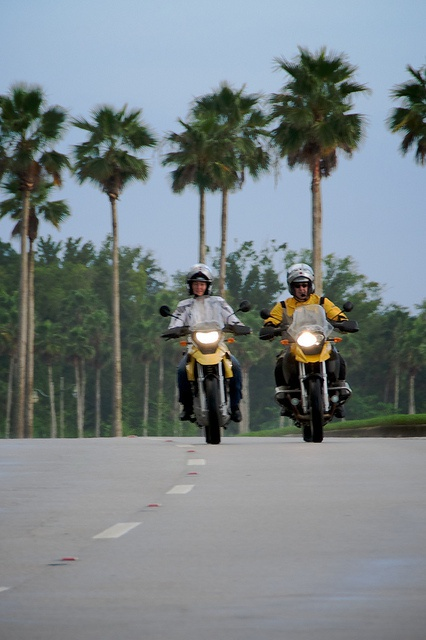Describe the objects in this image and their specific colors. I can see motorcycle in lightblue, black, darkgray, gray, and darkgreen tones, motorcycle in lightblue, black, gray, and darkgray tones, people in lightblue, black, darkgray, and gray tones, and people in lightblue, black, olive, gray, and darkgray tones in this image. 